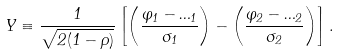Convert formula to latex. <formula><loc_0><loc_0><loc_500><loc_500>Y \equiv \frac { 1 } { \sqrt { 2 ( 1 - \rho ) } } \left [ \left ( \frac { \varphi _ { 1 } - \Phi _ { 1 } } { \sigma _ { 1 } } \right ) - \left ( \frac { \varphi _ { 2 } - \Phi _ { 2 } } { \sigma _ { 2 } } \right ) \right ] .</formula> 